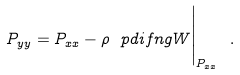Convert formula to latex. <formula><loc_0><loc_0><loc_500><loc_500>P _ { y y } = P _ { x x } - \rho \ p d i f n { g } { W } \Big | _ { P _ { x x } } \ .</formula> 